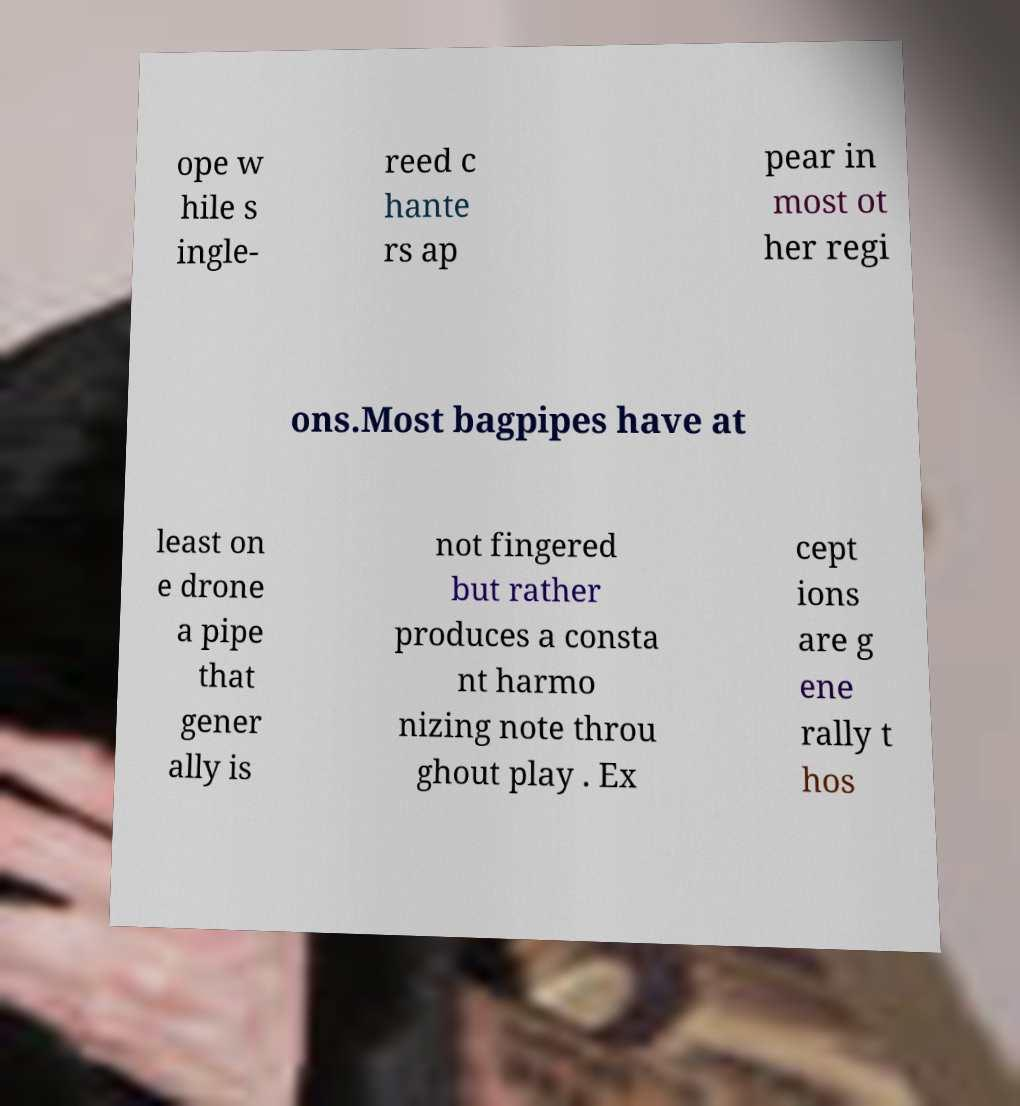I need the written content from this picture converted into text. Can you do that? ope w hile s ingle- reed c hante rs ap pear in most ot her regi ons.Most bagpipes have at least on e drone a pipe that gener ally is not fingered but rather produces a consta nt harmo nizing note throu ghout play . Ex cept ions are g ene rally t hos 